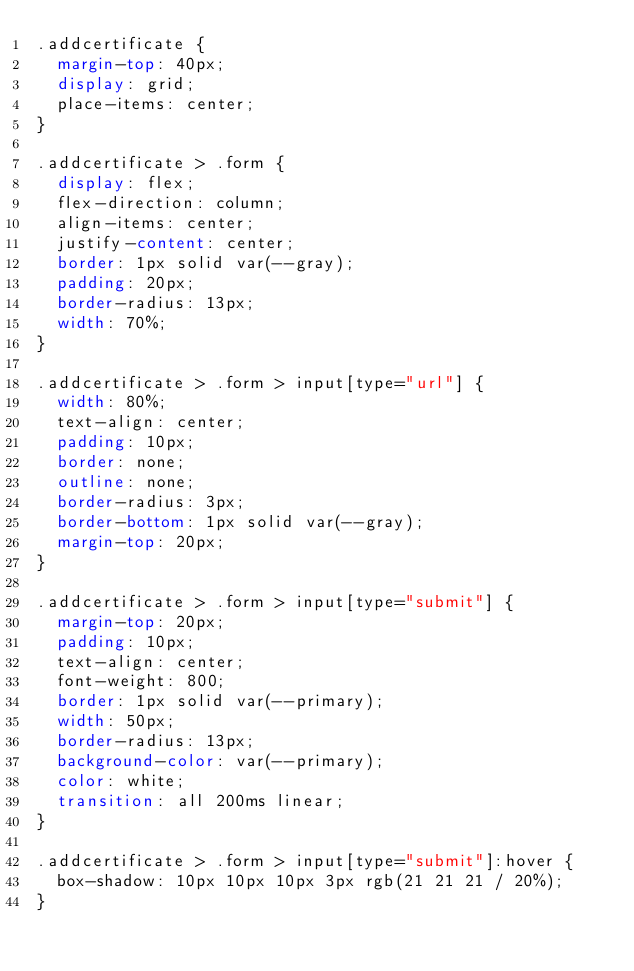<code> <loc_0><loc_0><loc_500><loc_500><_CSS_>.addcertificate {
  margin-top: 40px;
  display: grid;
  place-items: center;
}

.addcertificate > .form {
  display: flex;
  flex-direction: column;
  align-items: center;
  justify-content: center;
  border: 1px solid var(--gray);
  padding: 20px;
  border-radius: 13px;
  width: 70%;
}

.addcertificate > .form > input[type="url"] {
  width: 80%;
  text-align: center;
  padding: 10px;
  border: none;
  outline: none;
  border-radius: 3px;
  border-bottom: 1px solid var(--gray);
  margin-top: 20px;
}

.addcertificate > .form > input[type="submit"] {
  margin-top: 20px;
  padding: 10px;
  text-align: center;
  font-weight: 800;
  border: 1px solid var(--primary);
  width: 50px;
  border-radius: 13px;
  background-color: var(--primary);
  color: white;
  transition: all 200ms linear;
}

.addcertificate > .form > input[type="submit"]:hover {
  box-shadow: 10px 10px 10px 3px rgb(21 21 21 / 20%);
}
</code> 